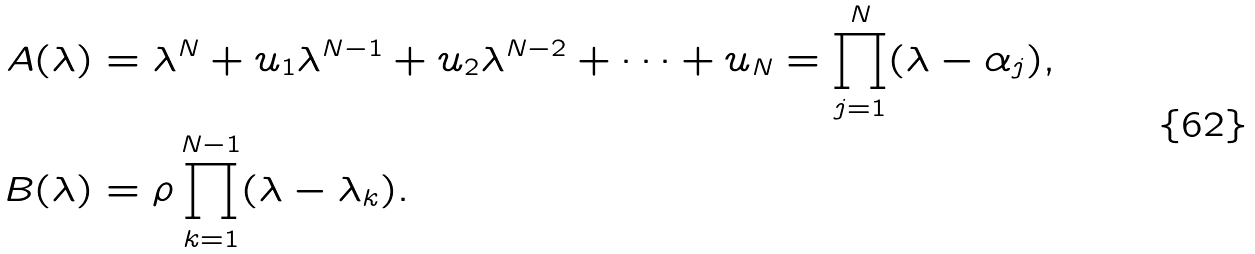Convert formula to latex. <formula><loc_0><loc_0><loc_500><loc_500>A ( \lambda ) & = \lambda ^ { N } + u _ { 1 } \lambda ^ { N - 1 } + u _ { 2 } \lambda ^ { N - 2 } + \cdots + u _ { N } = \prod _ { j = 1 } ^ { N } ( \lambda - \alpha _ { j } ) , \\ B ( \lambda ) & = \rho \prod _ { k = 1 } ^ { N - 1 } ( \lambda - \lambda _ { k } ) .</formula> 